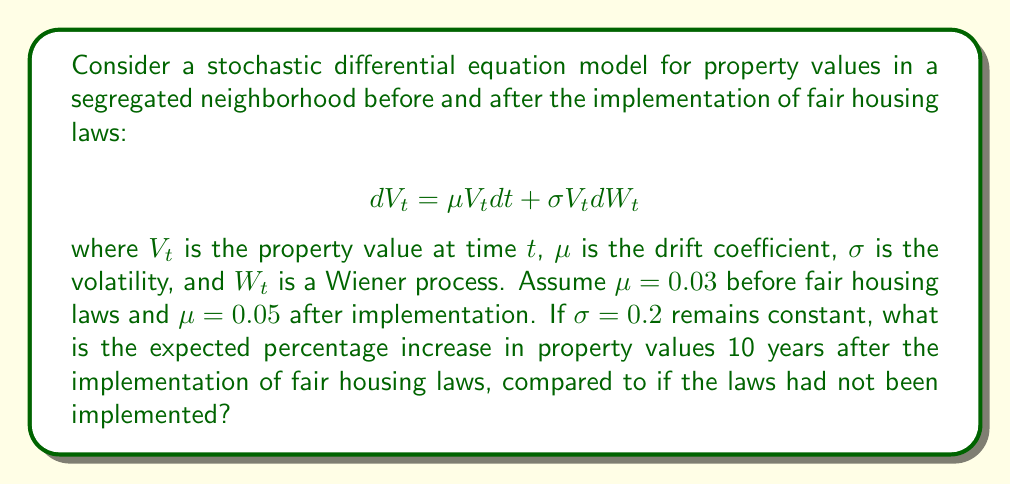Solve this math problem. To solve this problem, we'll use the properties of geometric Brownian motion, which is the solution to the given stochastic differential equation.

1. The expected value of $V_t$ for geometric Brownian motion is given by:
   $$E[V_t] = V_0 e^{\mu t}$$

2. Let's define two scenarios:
   a) Without fair housing laws: $\mu_1 = 0.03$
   b) With fair housing laws: $\mu_2 = 0.05$

3. Calculate the expected value after 10 years for each scenario:
   a) $E[V_{10}]_1 = V_0 e^{0.03 \cdot 10} = V_0 e^{0.3}$
   b) $E[V_{10}]_2 = V_0 e^{0.05 \cdot 10} = V_0 e^{0.5}$

4. Calculate the ratio of these expected values:
   $$\frac{E[V_{10}]_2}{E[V_{10}]_1} = \frac{V_0 e^{0.5}}{V_0 e^{0.3}} = e^{0.5 - 0.3} = e^{0.2}$$

5. Convert this ratio to a percentage increase:
   Percentage increase = $(e^{0.2} - 1) \cdot 100\% \approx 22.14\%$

Therefore, the expected percentage increase in property values 10 years after the implementation of fair housing laws is approximately 22.14%.
Answer: 22.14% 